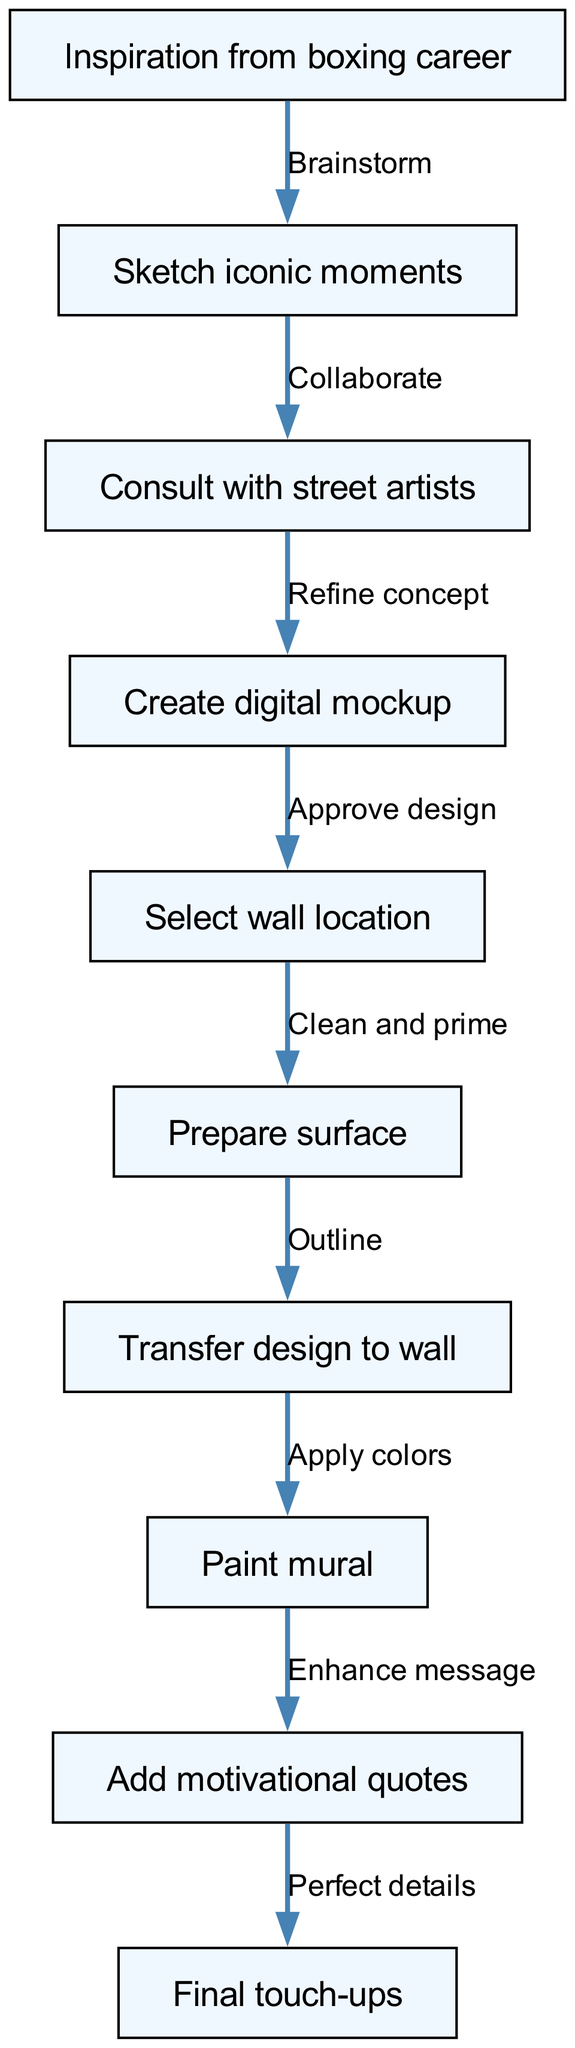What is the starting point of the mural design process? The starting point, as indicated in the diagram, is "Inspiration from boxing career". This is where the entire process begins.
Answer: Inspiration from boxing career How many nodes are there in total? By counting all the distinct steps labeled in the diagram, there are ten nodes representing different stages in the mural design process.
Answer: 10 What is the final step in the mural design process? The last node in the flowchart signifies "Final touch-ups", which represents the concluding step of the design process.
Answer: Final touch-ups Which two nodes are connected by the label "Collaborate"? The "Sketch iconic moments" node leads to the "Consult with street artists" node, marked by the label "Collaborate". This indicates the collaboration phase after sketching.
Answer: Sketch iconic moments and Consult with street artists What step comes before "Prepare surface"? The process flows from "Select wall location" directly to "Prepare surface", indicating that locating the wall is necessary before surface preparation.
Answer: Select wall location What is the significance of the edge labeled "Enhance message"? This edge connects "Paint mural" with "Add motivational quotes", showing the focus on message enhancement after the mural is painted.
Answer: Enhance message What are the two nodes involved in the "Refine concept" relationship? The relationship labeled "Refine concept" connects "Consult with street artists" and "Create digital mockup", indicating refinement takes place after consultation.
Answer: Consult with street artists and Create digital mockup Which step occurs after "Transfer design to wall"? The diagram shows that the step following "Transfer design to wall" is "Paint mural", which is the next phase of execution.
Answer: Paint mural What is the overall direction of the flowchart? The flowchart flows from top to bottom, indicating a sequential process moving through various stages from start to finish.
Answer: Top to bottom 